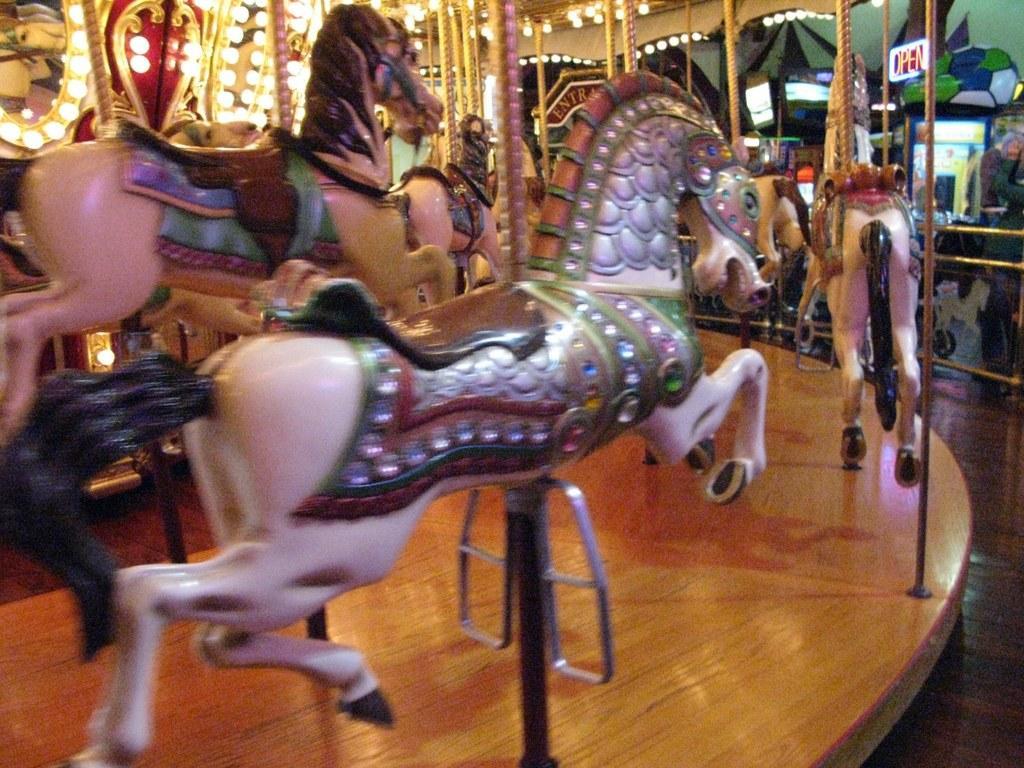Describe this image in one or two sentences. In this image there are dolls in the shape of horses. On the left side there are lights, on the right side there is a digital board Open in red color. 